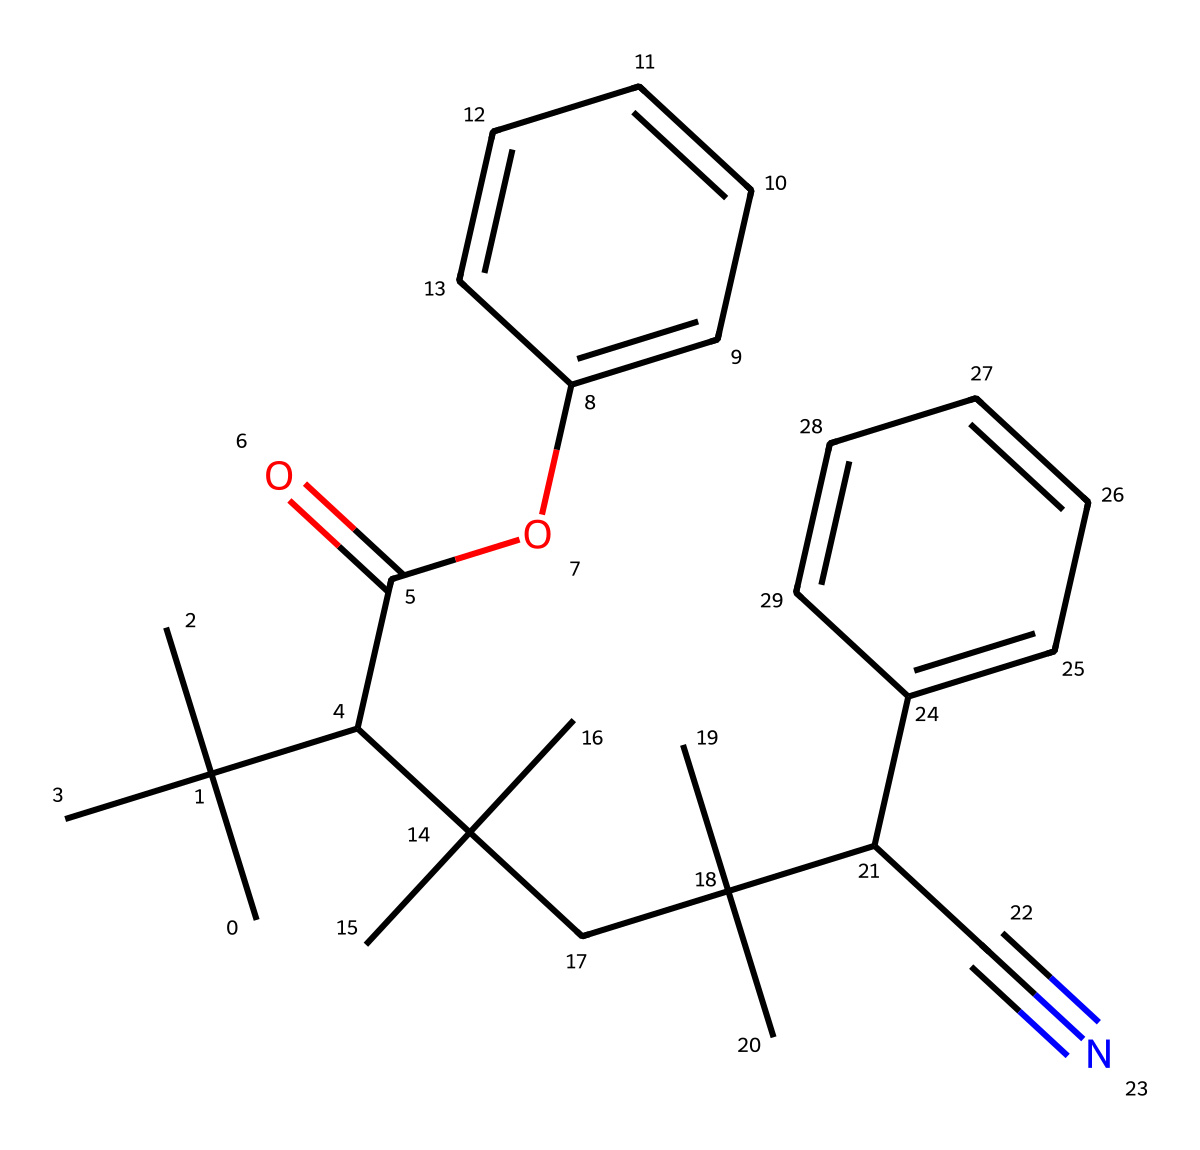What is the primary functional group in this ABS plastic composition? The structure contains an ester functional group, indicated by the -C(=O)O- part of the molecule. This is characteristic of an ester linkage present in some types of plastics, providing flexibility and durability.
Answer: ester How many aromatic rings are included in the structure? The molecule contains two distinct aromatic rings, as indicated by the two sets of alternating double bonds within the structure. Each benzene-like structure represents one aromatic ring.
Answer: 2 What element is the dominant in number in this chemical representation? When counting the distinct atoms, carbon is present in the highest quantity within the structure. In most organic compounds, including plastics, carbon atoms typically form the backbone.
Answer: carbon Which part of the molecule contributes to its rigidity? The presence of the aromatic rings contributes significantly to the rigidity of the molecular structure. Aromatic compounds are known to provide strength and rigidity due to their stable ring structure.
Answer: aromatic rings What is the total number of nitrogen atoms shown in this chemical? The molecular structure includes a single nitrogen atom, identified by the -C#N (nitrile group), which is distinctly represented as part of the overall composition.
Answer: 1 What type of material does this chemical structure represent? This chemical structure represents ABS plastic, which is known for its high impact resistance and toughness, typically used in applications such as keyboard keycaps.
Answer: ABS plastic 